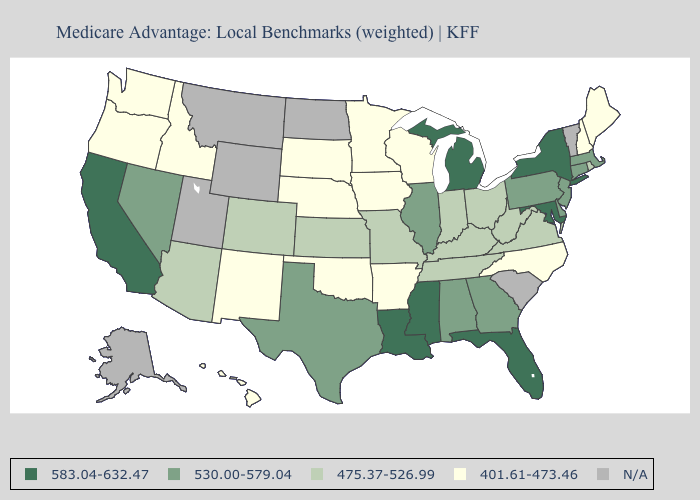What is the value of Tennessee?
Give a very brief answer. 475.37-526.99. What is the value of North Dakota?
Be succinct. N/A. Does Idaho have the lowest value in the USA?
Give a very brief answer. Yes. Which states have the highest value in the USA?
Keep it brief. California, Florida, Louisiana, Maryland, Michigan, Mississippi, New York. What is the value of Missouri?
Give a very brief answer. 475.37-526.99. Which states have the lowest value in the USA?
Answer briefly. Arkansas, Hawaii, Iowa, Idaho, Maine, Minnesota, North Carolina, Nebraska, New Hampshire, New Mexico, Oklahoma, Oregon, South Dakota, Washington, Wisconsin. Among the states that border Idaho , does Nevada have the highest value?
Give a very brief answer. Yes. What is the highest value in the Northeast ?
Short answer required. 583.04-632.47. Among the states that border Pennsylvania , which have the lowest value?
Give a very brief answer. Ohio, West Virginia. What is the value of Alaska?
Be succinct. N/A. Does the map have missing data?
Give a very brief answer. Yes. Among the states that border Illinois , which have the lowest value?
Write a very short answer. Iowa, Wisconsin. 